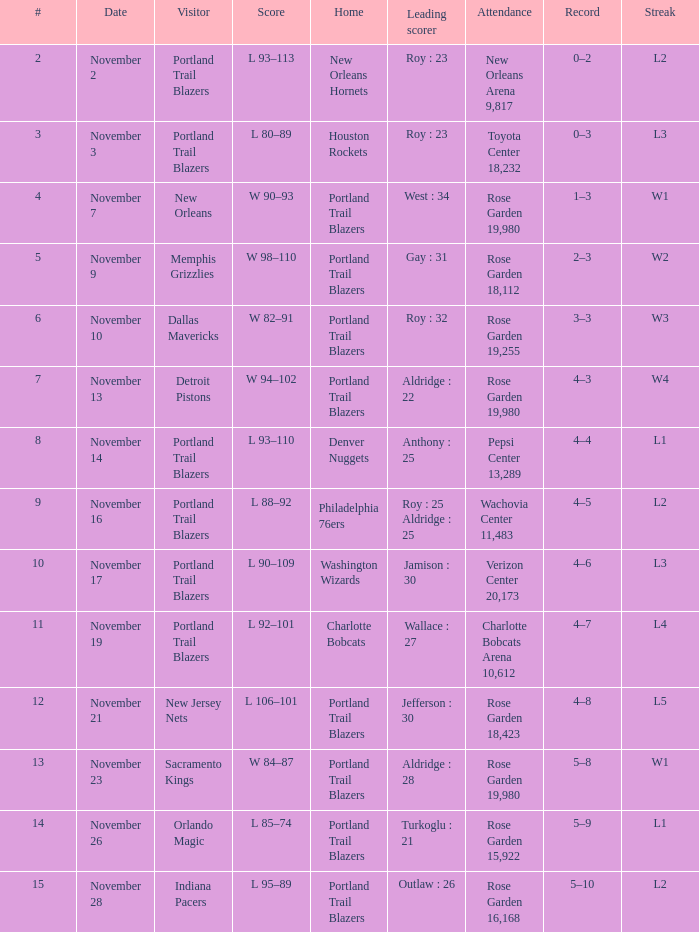On how many occasions were the new jersey nets the visiting team? 1.0. 